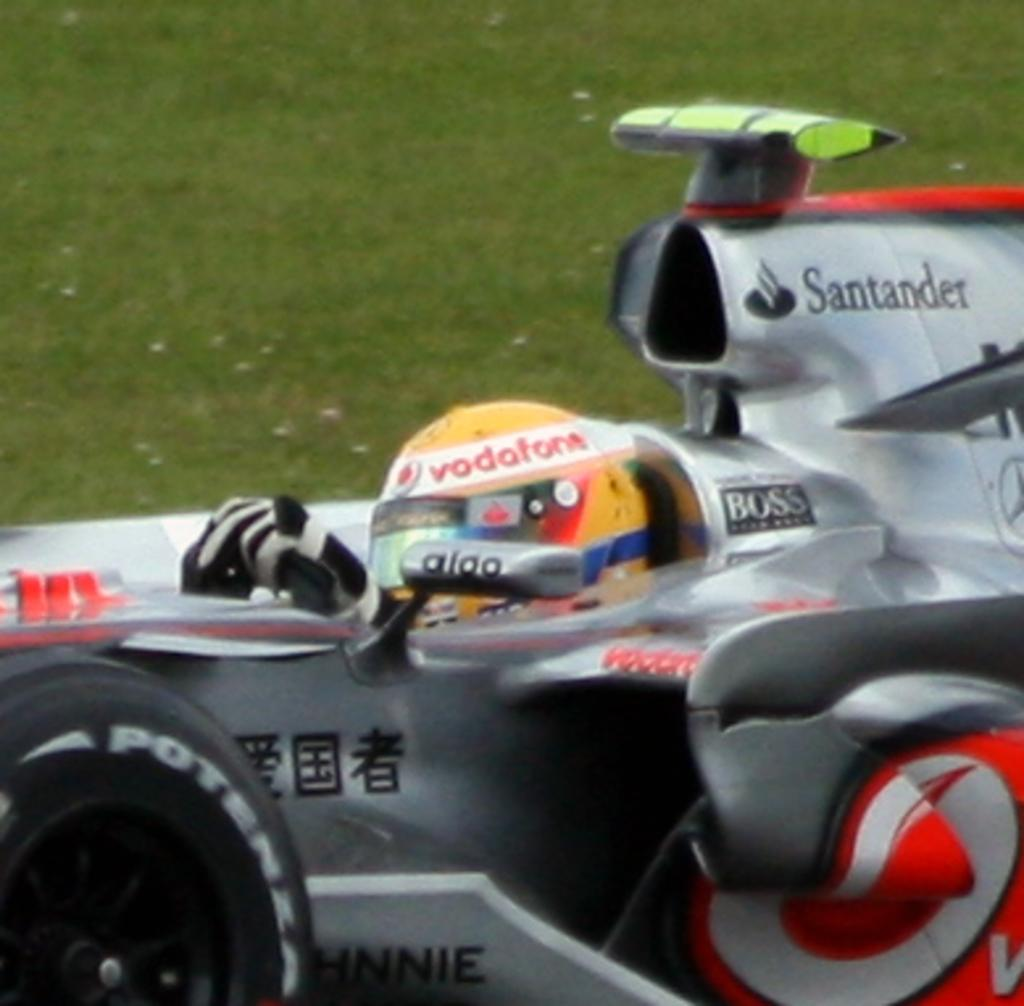<image>
Create a compact narrative representing the image presented. A man wearing a Vodofon helmet is riding in a racecar. 